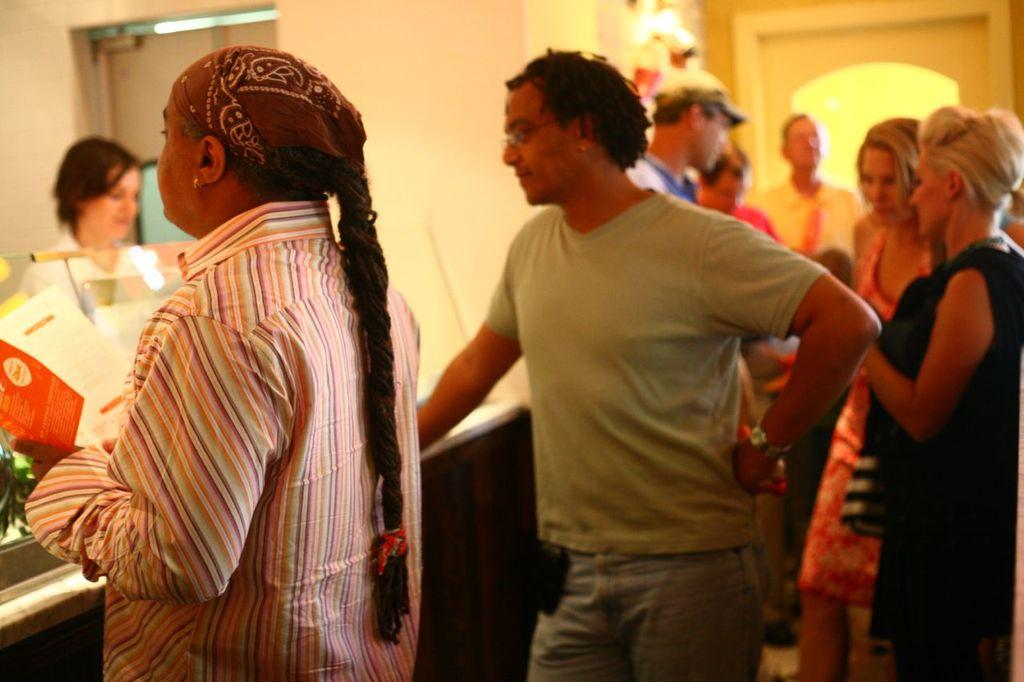What can be seen in the image involving people? There are people standing in the image. What object is visible that might be used for drinking? There is a glass in the image. What piece of furniture is present in the image? There is a table in the image. What can be seen in the background of the image? There is a wall and a door in the background of the image. What type of berry is being used to hold the door open in the image? There is no berry present in the image, and the door is not being held open. 